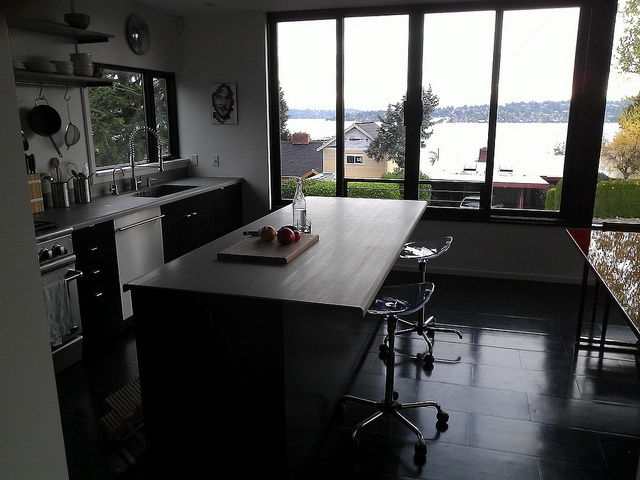Describe the objects in this image and their specific colors. I can see dining table in black, darkgray, gray, and lightgray tones, dining table in black, gray, darkgray, and lightgray tones, oven in black, gray, darkgray, and purple tones, chair in black, gray, and darkgray tones, and chair in black, gray, darkgray, and lightgray tones in this image. 